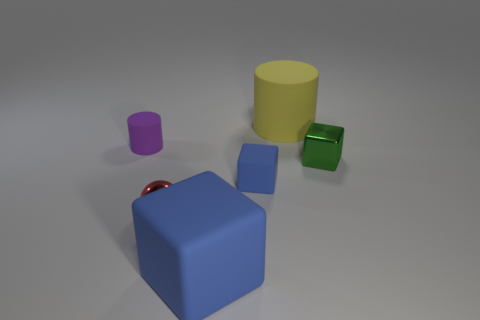The small ball has what color?
Give a very brief answer. Red. Are there any small balls that have the same color as the large rubber block?
Offer a terse response. No. Do the thing behind the purple rubber thing and the big block have the same color?
Keep it short and to the point. No. How many things are either matte objects that are on the right side of the purple matte cylinder or tiny blue objects?
Ensure brevity in your answer.  3. Are there any blue rubber cubes behind the small green object?
Give a very brief answer. No. There is a small cube that is the same color as the large matte cube; what material is it?
Give a very brief answer. Rubber. Do the big thing in front of the yellow object and the big cylinder have the same material?
Your response must be concise. Yes. There is a cylinder that is in front of the large thing that is behind the small green thing; are there any small metallic spheres behind it?
Your answer should be very brief. No. What number of blocks are tiny blue rubber objects or big objects?
Your answer should be compact. 2. What material is the blue block to the right of the big rubber cube?
Make the answer very short. Rubber. 